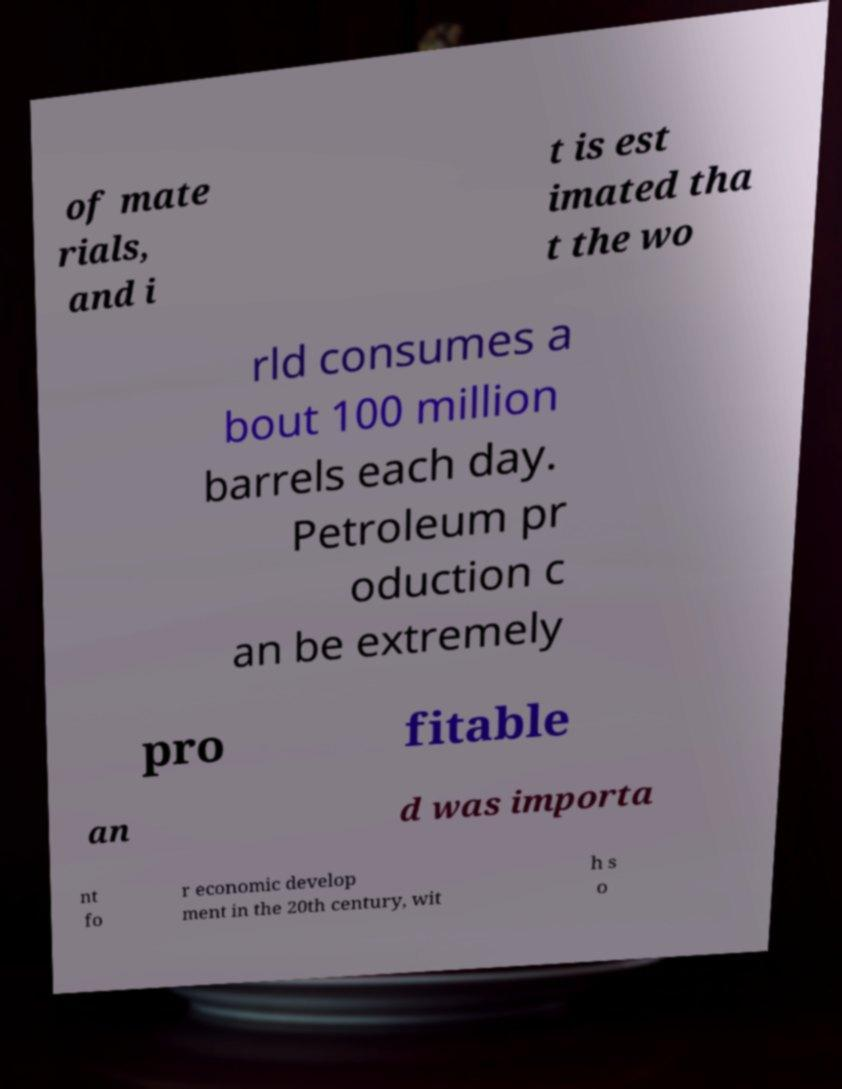Could you extract and type out the text from this image? of mate rials, and i t is est imated tha t the wo rld consumes a bout 100 million barrels each day. Petroleum pr oduction c an be extremely pro fitable an d was importa nt fo r economic develop ment in the 20th century, wit h s o 